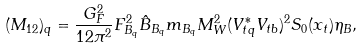Convert formula to latex. <formula><loc_0><loc_0><loc_500><loc_500>( M _ { 1 2 } ) _ { q } = \frac { G _ { F } ^ { 2 } } { 1 2 \pi ^ { 2 } } F _ { B _ { q } } ^ { 2 } \hat { B } _ { B _ { q } } m _ { B _ { q } } M _ { W } ^ { 2 } ( V _ { t q } ^ { * } V _ { t b } ) ^ { 2 } S _ { 0 } ( x _ { t } ) \eta _ { B } ,</formula> 